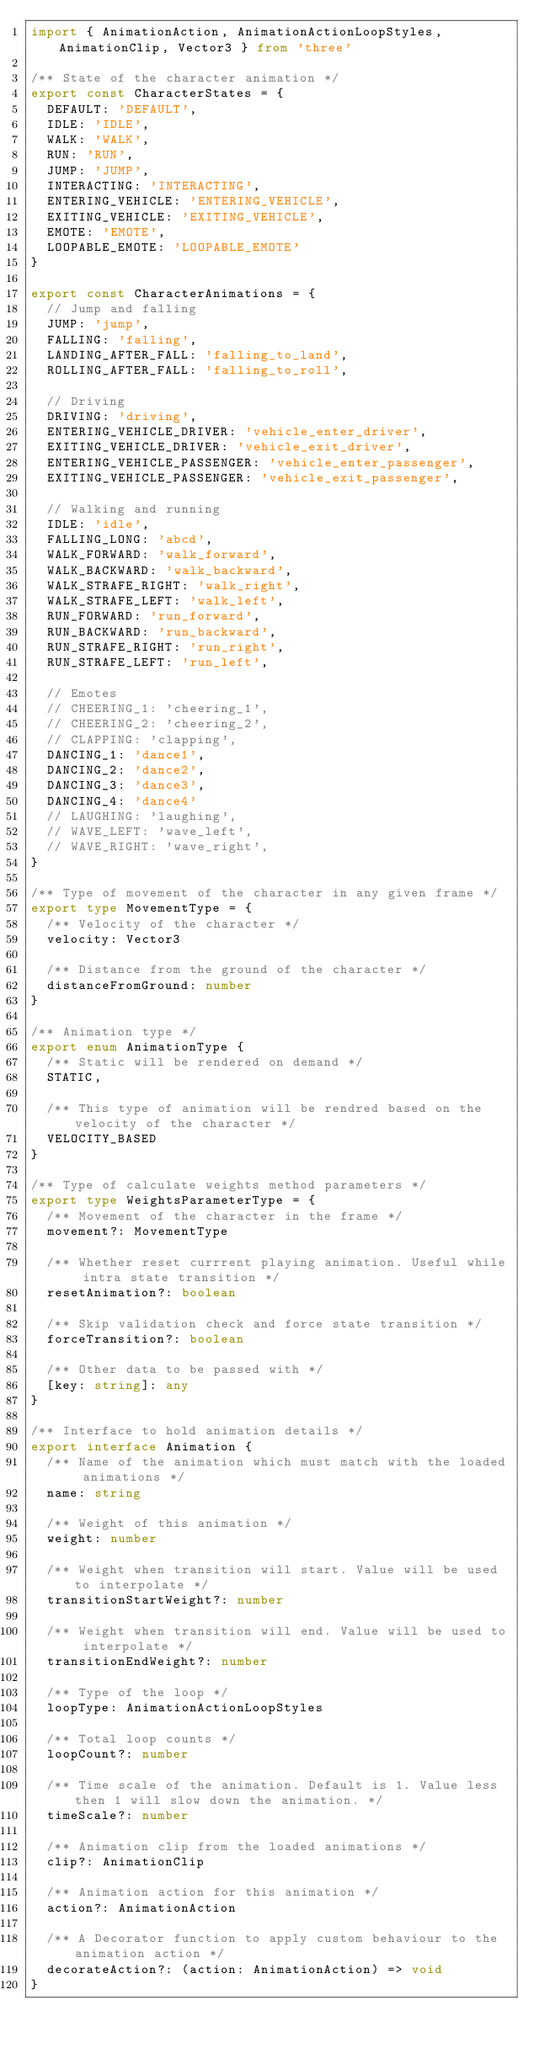<code> <loc_0><loc_0><loc_500><loc_500><_TypeScript_>import { AnimationAction, AnimationActionLoopStyles, AnimationClip, Vector3 } from 'three'

/** State of the character animation */
export const CharacterStates = {
  DEFAULT: 'DEFAULT',
  IDLE: 'IDLE',
  WALK: 'WALK',
  RUN: 'RUN',
  JUMP: 'JUMP',
  INTERACTING: 'INTERACTING',
  ENTERING_VEHICLE: 'ENTERING_VEHICLE',
  EXITING_VEHICLE: 'EXITING_VEHICLE',
  EMOTE: 'EMOTE',
  LOOPABLE_EMOTE: 'LOOPABLE_EMOTE'
}

export const CharacterAnimations = {
  // Jump and falling
  JUMP: 'jump',
  FALLING: 'falling',
  LANDING_AFTER_FALL: 'falling_to_land',
  ROLLING_AFTER_FALL: 'falling_to_roll',

  // Driving
  DRIVING: 'driving',
  ENTERING_VEHICLE_DRIVER: 'vehicle_enter_driver',
  EXITING_VEHICLE_DRIVER: 'vehicle_exit_driver',
  ENTERING_VEHICLE_PASSENGER: 'vehicle_enter_passenger',
  EXITING_VEHICLE_PASSENGER: 'vehicle_exit_passenger',

  // Walking and running
  IDLE: 'idle',
  FALLING_LONG: 'abcd',
  WALK_FORWARD: 'walk_forward',
  WALK_BACKWARD: 'walk_backward',
  WALK_STRAFE_RIGHT: 'walk_right',
  WALK_STRAFE_LEFT: 'walk_left',
  RUN_FORWARD: 'run_forward',
  RUN_BACKWARD: 'run_backward',
  RUN_STRAFE_RIGHT: 'run_right',
  RUN_STRAFE_LEFT: 'run_left',

  // Emotes
  // CHEERING_1: 'cheering_1',
  // CHEERING_2: 'cheering_2',
  // CLAPPING: 'clapping',
  DANCING_1: 'dance1',
  DANCING_2: 'dance2',
  DANCING_3: 'dance3',
  DANCING_4: 'dance4'
  // LAUGHING: 'laughing',
  // WAVE_LEFT: 'wave_left',
  // WAVE_RIGHT: 'wave_right',
}

/** Type of movement of the character in any given frame */
export type MovementType = {
  /** Velocity of the character */
  velocity: Vector3

  /** Distance from the ground of the character */
  distanceFromGround: number
}

/** Animation type */
export enum AnimationType {
  /** Static will be rendered on demand */
  STATIC,

  /** This type of animation will be rendred based on the velocity of the character */
  VELOCITY_BASED
}

/** Type of calculate weights method parameters */
export type WeightsParameterType = {
  /** Movement of the character in the frame */
  movement?: MovementType

  /** Whether reset currrent playing animation. Useful while intra state transition */
  resetAnimation?: boolean

  /** Skip validation check and force state transition */
  forceTransition?: boolean

  /** Other data to be passed with */
  [key: string]: any
}

/** Interface to hold animation details */
export interface Animation {
  /** Name of the animation which must match with the loaded animations */
  name: string

  /** Weight of this animation */
  weight: number

  /** Weight when transition will start. Value will be used to interpolate */
  transitionStartWeight?: number

  /** Weight when transition will end. Value will be used to interpolate */
  transitionEndWeight?: number

  /** Type of the loop */
  loopType: AnimationActionLoopStyles

  /** Total loop counts */
  loopCount?: number

  /** Time scale of the animation. Default is 1. Value less then 1 will slow down the animation. */
  timeScale?: number

  /** Animation clip from the loaded animations */
  clip?: AnimationClip

  /** Animation action for this animation */
  action?: AnimationAction

  /** A Decorator function to apply custom behaviour to the animation action */
  decorateAction?: (action: AnimationAction) => void
}
</code> 